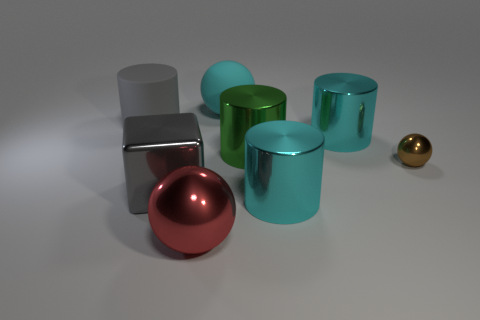The big metallic object that is the same shape as the small shiny thing is what color?
Provide a succinct answer. Red. What is the size of the cyan shiny object that is behind the small brown metallic thing?
Ensure brevity in your answer.  Large. There is a large sphere that is in front of the gray metal object that is to the left of the big green cylinder; how many large red objects are in front of it?
Make the answer very short. 0. There is a red metal sphere; are there any cyan spheres behind it?
Keep it short and to the point. Yes. What number of other things are there of the same size as the red shiny sphere?
Keep it short and to the point. 6. There is a thing that is both in front of the tiny brown sphere and to the right of the cyan rubber object; what material is it?
Your answer should be very brief. Metal. Do the rubber object that is right of the gray cylinder and the rubber thing that is in front of the cyan rubber object have the same shape?
Give a very brief answer. No. Is there any other thing that is the same material as the large green object?
Give a very brief answer. Yes. There is a big gray thing in front of the shiny ball to the right of the big sphere that is behind the green cylinder; what is its shape?
Give a very brief answer. Cube. What number of other things are the same shape as the big gray matte object?
Your answer should be compact. 3. 